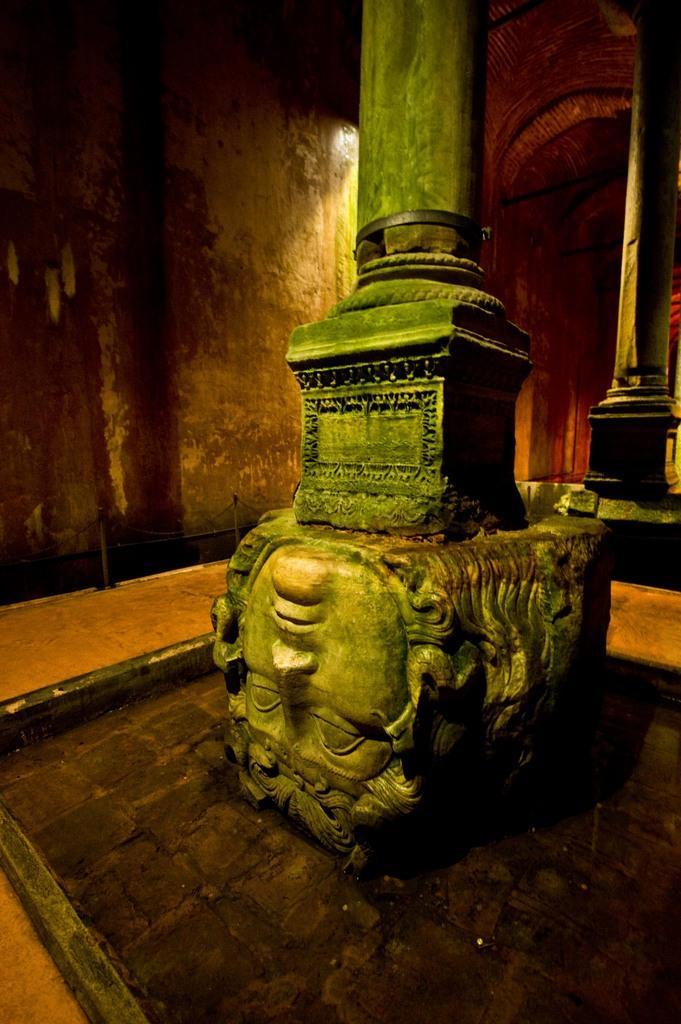Could you give a brief overview of what you see in this image? In this picture I can see statues of faces and poles. In the background I can see a wall and light. 